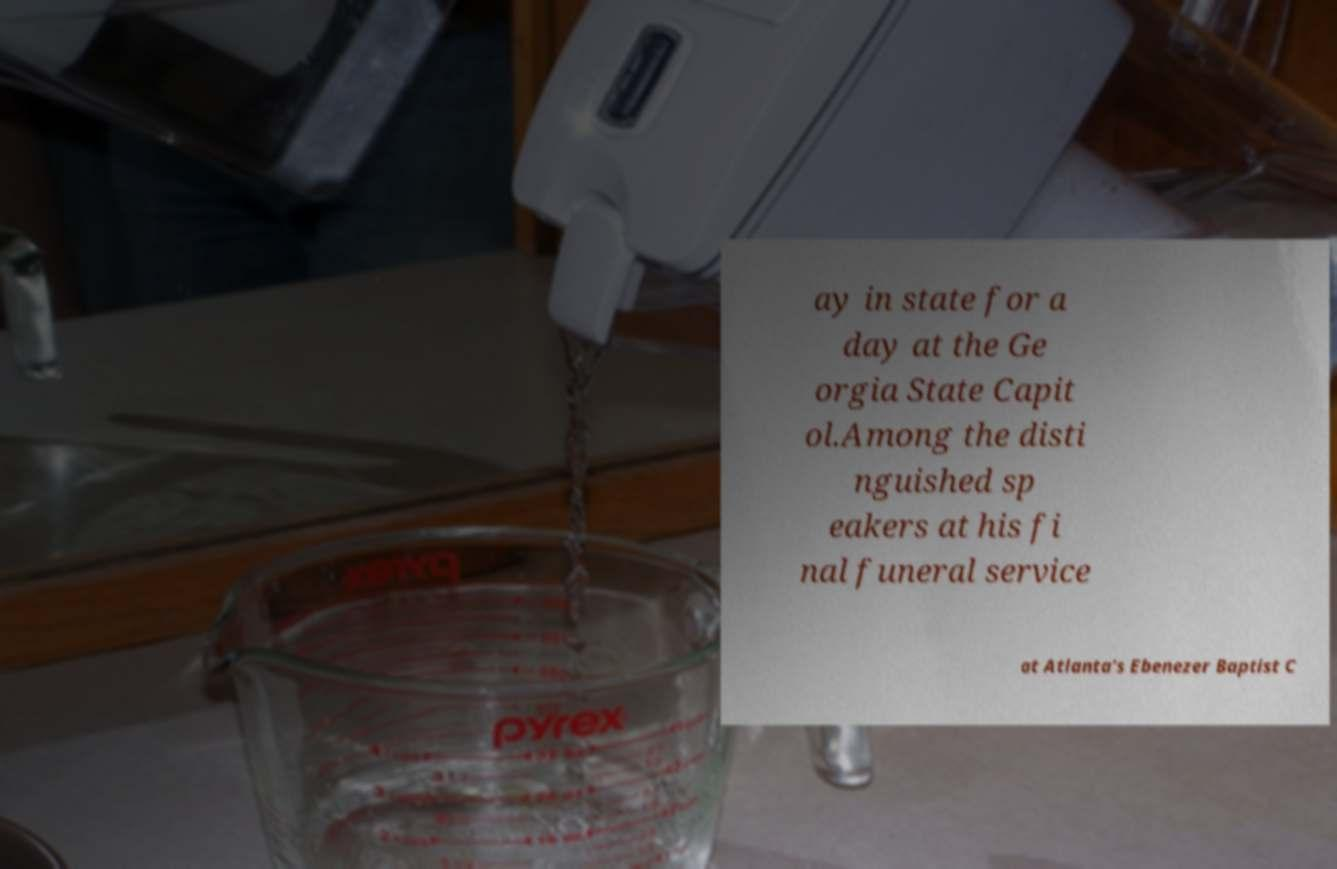For documentation purposes, I need the text within this image transcribed. Could you provide that? ay in state for a day at the Ge orgia State Capit ol.Among the disti nguished sp eakers at his fi nal funeral service at Atlanta's Ebenezer Baptist C 